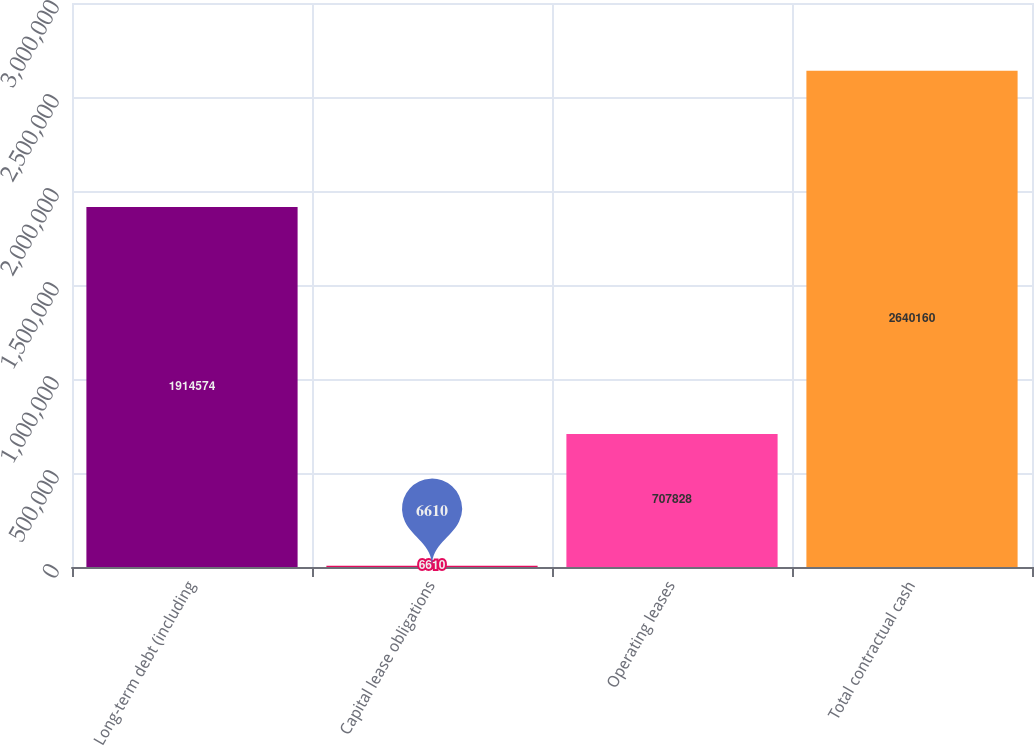Convert chart to OTSL. <chart><loc_0><loc_0><loc_500><loc_500><bar_chart><fcel>Long-term debt (including<fcel>Capital lease obligations<fcel>Operating leases<fcel>Total contractual cash<nl><fcel>1.91457e+06<fcel>6610<fcel>707828<fcel>2.64016e+06<nl></chart> 